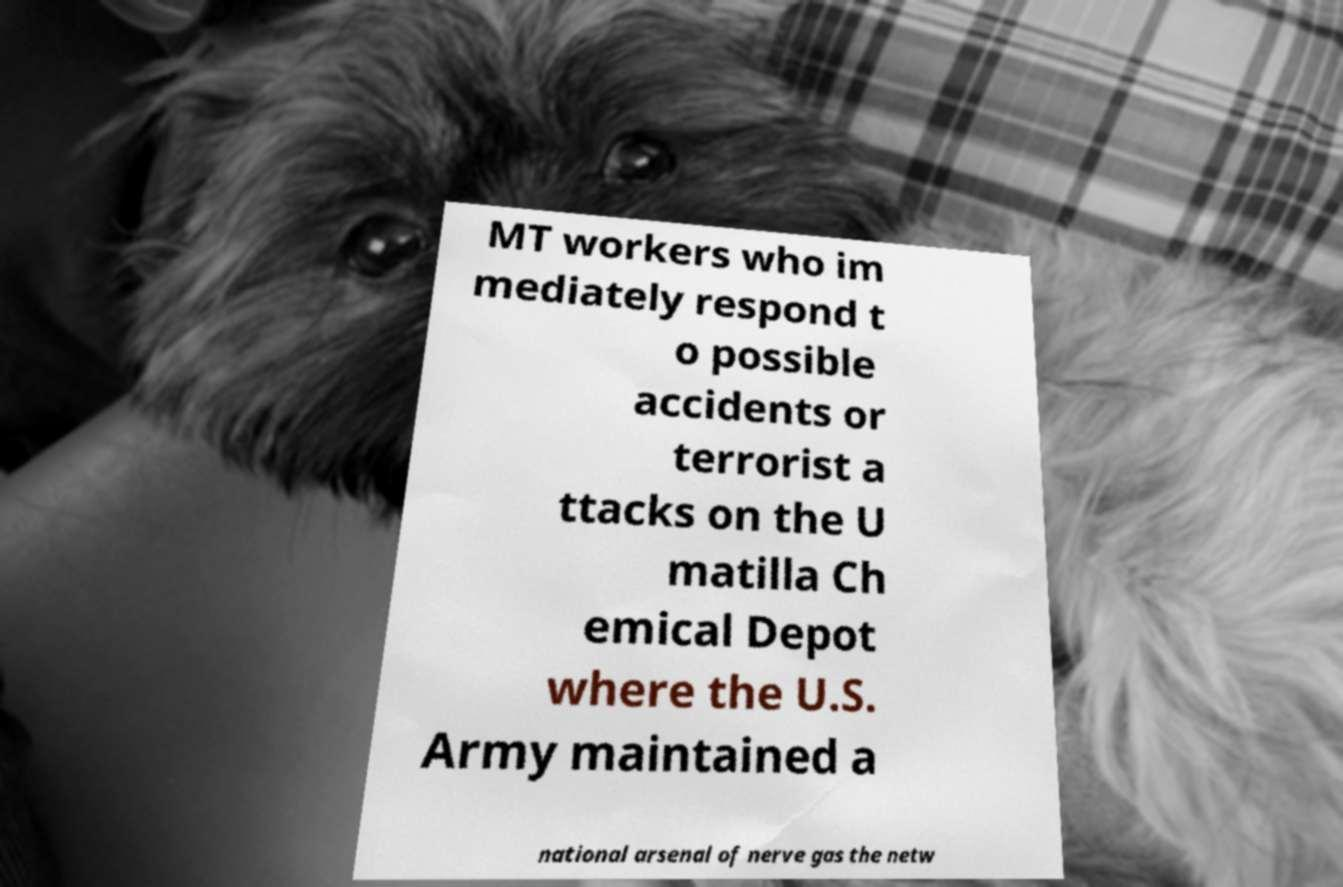There's text embedded in this image that I need extracted. Can you transcribe it verbatim? MT workers who im mediately respond t o possible accidents or terrorist a ttacks on the U matilla Ch emical Depot where the U.S. Army maintained a national arsenal of nerve gas the netw 